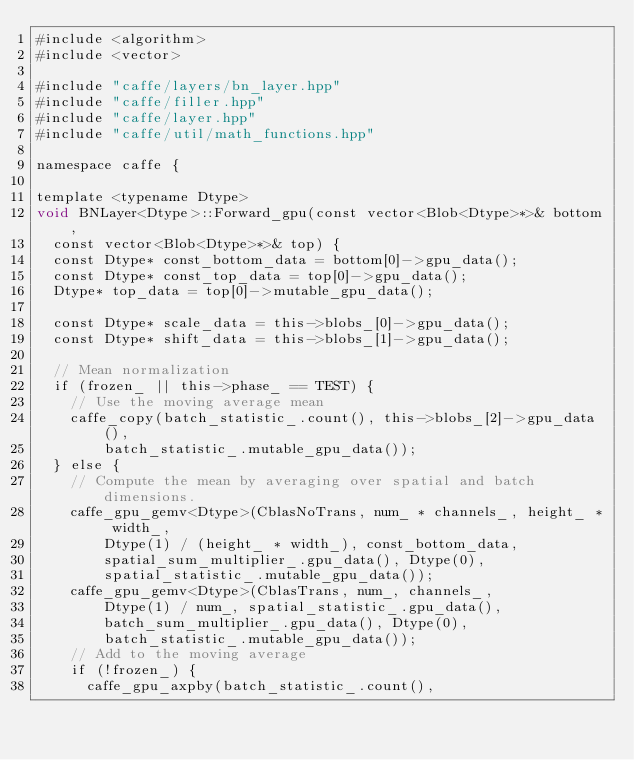Convert code to text. <code><loc_0><loc_0><loc_500><loc_500><_Cuda_>#include <algorithm>
#include <vector>

#include "caffe/layers/bn_layer.hpp"
#include "caffe/filler.hpp"
#include "caffe/layer.hpp"
#include "caffe/util/math_functions.hpp"

namespace caffe {

template <typename Dtype>
void BNLayer<Dtype>::Forward_gpu(const vector<Blob<Dtype>*>& bottom,
  const vector<Blob<Dtype>*>& top) {
  const Dtype* const_bottom_data = bottom[0]->gpu_data();
  const Dtype* const_top_data = top[0]->gpu_data();
  Dtype* top_data = top[0]->mutable_gpu_data();

  const Dtype* scale_data = this->blobs_[0]->gpu_data();
  const Dtype* shift_data = this->blobs_[1]->gpu_data();

  // Mean normalization
  if (frozen_ || this->phase_ == TEST) {
    // Use the moving average mean
    caffe_copy(batch_statistic_.count(), this->blobs_[2]->gpu_data(),
        batch_statistic_.mutable_gpu_data());
  } else {
    // Compute the mean by averaging over spatial and batch dimensions.
    caffe_gpu_gemv<Dtype>(CblasNoTrans, num_ * channels_, height_ * width_,
        Dtype(1) / (height_ * width_), const_bottom_data,
        spatial_sum_multiplier_.gpu_data(), Dtype(0),
        spatial_statistic_.mutable_gpu_data());
    caffe_gpu_gemv<Dtype>(CblasTrans, num_, channels_,
        Dtype(1) / num_, spatial_statistic_.gpu_data(),
        batch_sum_multiplier_.gpu_data(), Dtype(0),
        batch_statistic_.mutable_gpu_data());
    // Add to the moving average
    if (!frozen_) {
      caffe_gpu_axpby(batch_statistic_.count(),</code> 